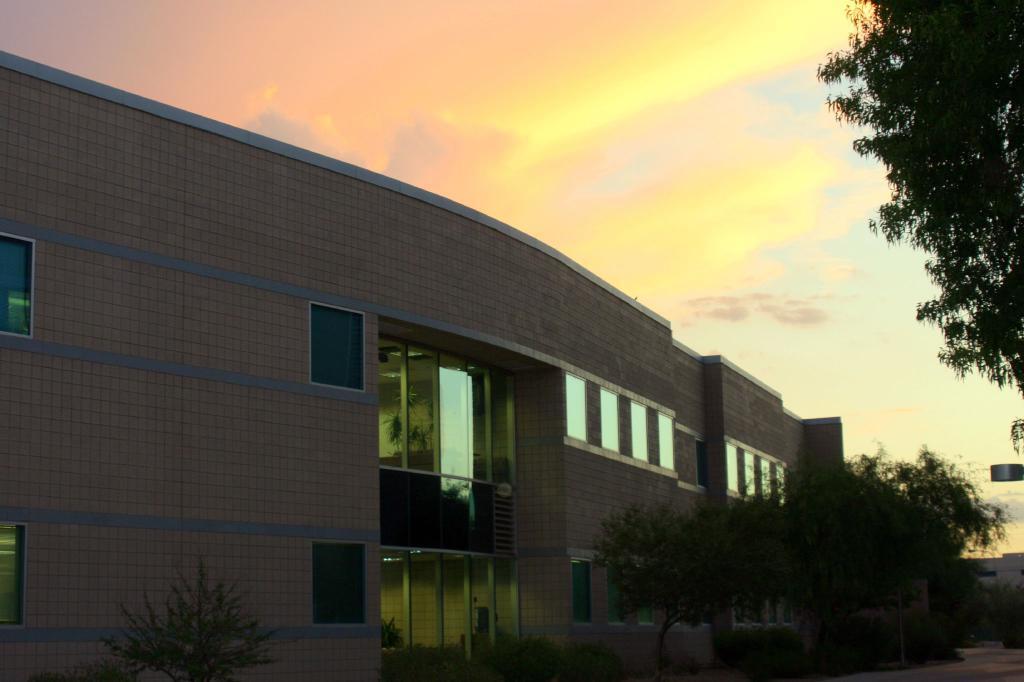Can you describe this image briefly? In this picture I can see plants, trees, there is a building, and in the background there is sky. 